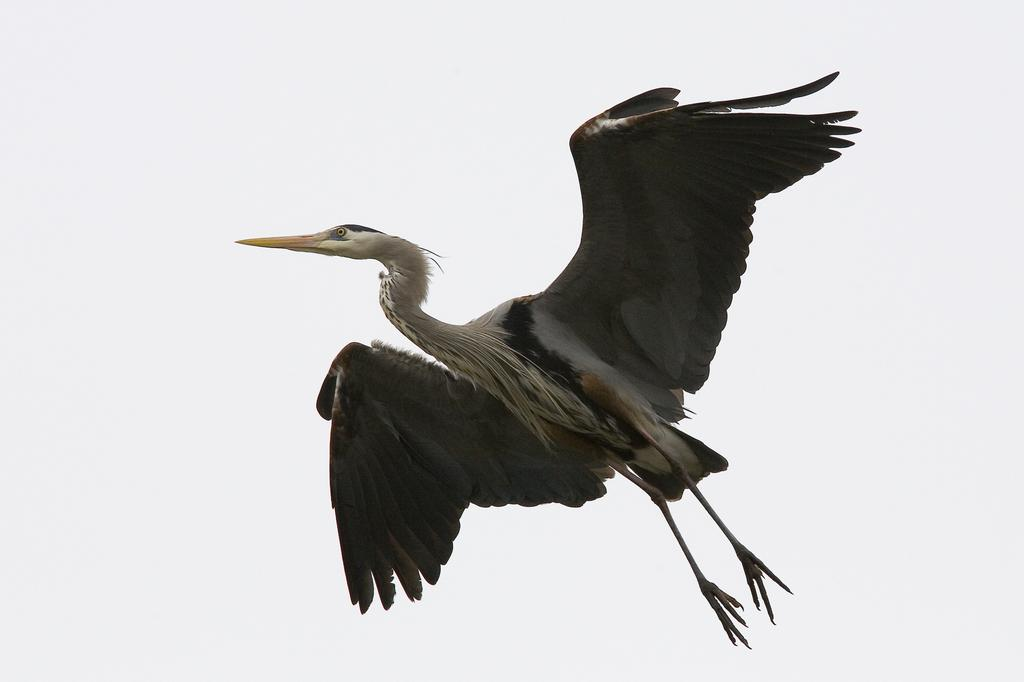Who is the main subject in the picture? There is a person (heroine) in the picture. What is the person doing in the image? The person is flying. What can be seen in the background of the image? There is sky visible in the image. What is the condition of the sky in the picture? Clouds are present in the sky. Can you tell me how many veins are visible on the person's arm in the image? There is no visible arm or veins present in the image, as the person is flying. What type of plastic object is being used by the person's mom in the image? There is no mom or plastic object present in the image, as the focus is on the person flying in the sky. 